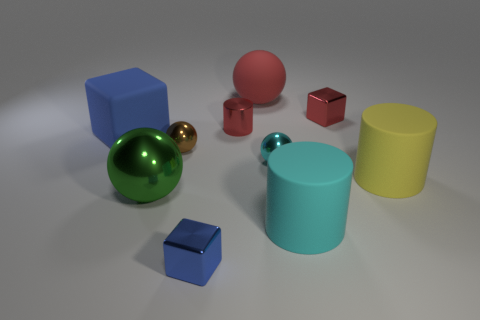What number of other things are there of the same size as the yellow matte thing?
Your response must be concise. 4. Do the cylinder that is behind the cyan metallic thing and the big metallic thing have the same color?
Your answer should be compact. No. Is the number of red metal things in front of the small cyan metal thing greater than the number of green spheres?
Offer a terse response. No. Is there anything else of the same color as the big metallic sphere?
Your answer should be compact. No. The red metallic thing in front of the red metal block behind the tiny brown object is what shape?
Offer a very short reply. Cylinder. Is the number of small metal blocks greater than the number of cyan rubber things?
Your response must be concise. Yes. How many metallic spheres are both to the right of the large green metallic object and left of the big red sphere?
Your answer should be compact. 1. How many blue cubes are on the right side of the rubber thing that is behind the large blue matte object?
Your response must be concise. 0. How many objects are blue cubes that are in front of the large blue thing or big matte objects right of the large green shiny sphere?
Provide a short and direct response. 4. There is a big green object that is the same shape as the small brown metal object; what is its material?
Keep it short and to the point. Metal. 